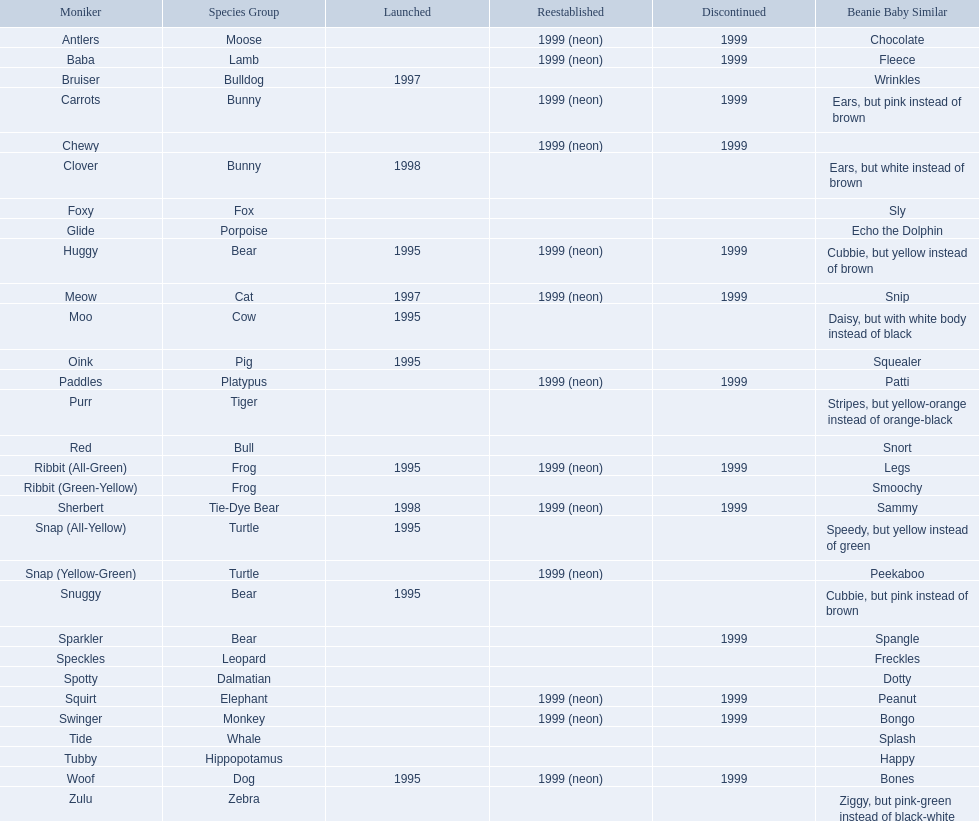What are the types of pillow pal animals? Antlers, Moose, Lamb, Bulldog, Bunny, , Bunny, Fox, Porpoise, Bear, Cat, Cow, Pig, Platypus, Tiger, Bull, Frog, Frog, Tie-Dye Bear, Turtle, Turtle, Bear, Bear, Leopard, Dalmatian, Elephant, Monkey, Whale, Hippopotamus, Dog, Zebra. Of those, which is a dalmatian? Dalmatian. What is the name of the dalmatian? Spotty. 